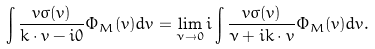Convert formula to latex. <formula><loc_0><loc_0><loc_500><loc_500>\int { \frac { v \sigma ( v ) } { k \cdot v - i 0 } \Phi _ { M } ( v ) d v } = \lim _ { \nu \rightarrow 0 } { i \int { \frac { v \sigma ( v ) } { \nu + i k \cdot v } \Phi _ { M } ( v ) d v } } .</formula> 